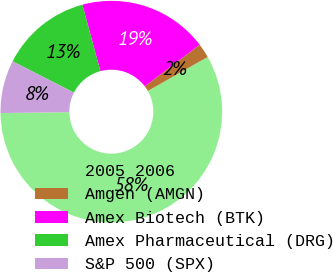Convert chart to OTSL. <chart><loc_0><loc_0><loc_500><loc_500><pie_chart><fcel>2005 2006<fcel>Amgen (AMGN)<fcel>Amex Biotech (BTK)<fcel>Amex Pharmaceutical (DRG)<fcel>S&P 500 (SPX)<nl><fcel>58.01%<fcel>2.11%<fcel>18.88%<fcel>13.29%<fcel>7.7%<nl></chart> 